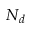Convert formula to latex. <formula><loc_0><loc_0><loc_500><loc_500>N _ { d }</formula> 